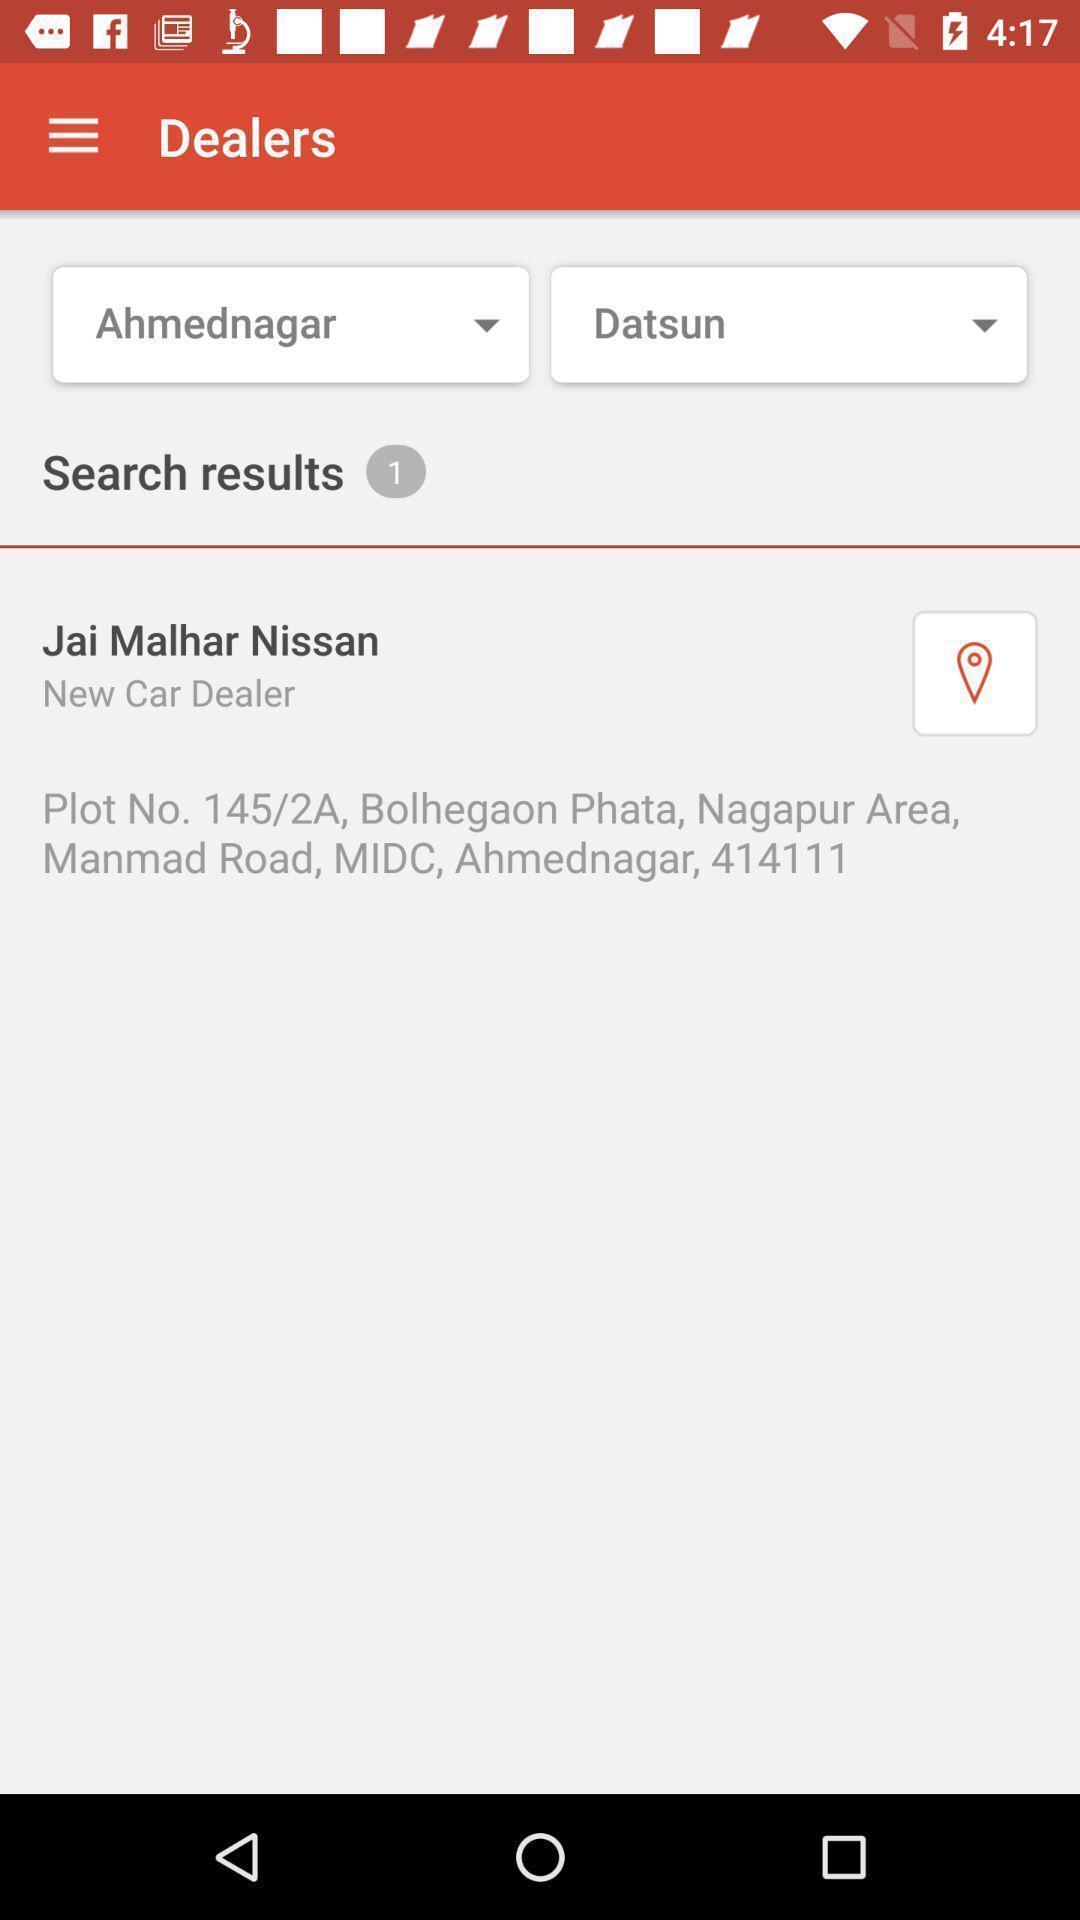Explain the elements present in this screenshot. Screen showing all the searched results. 